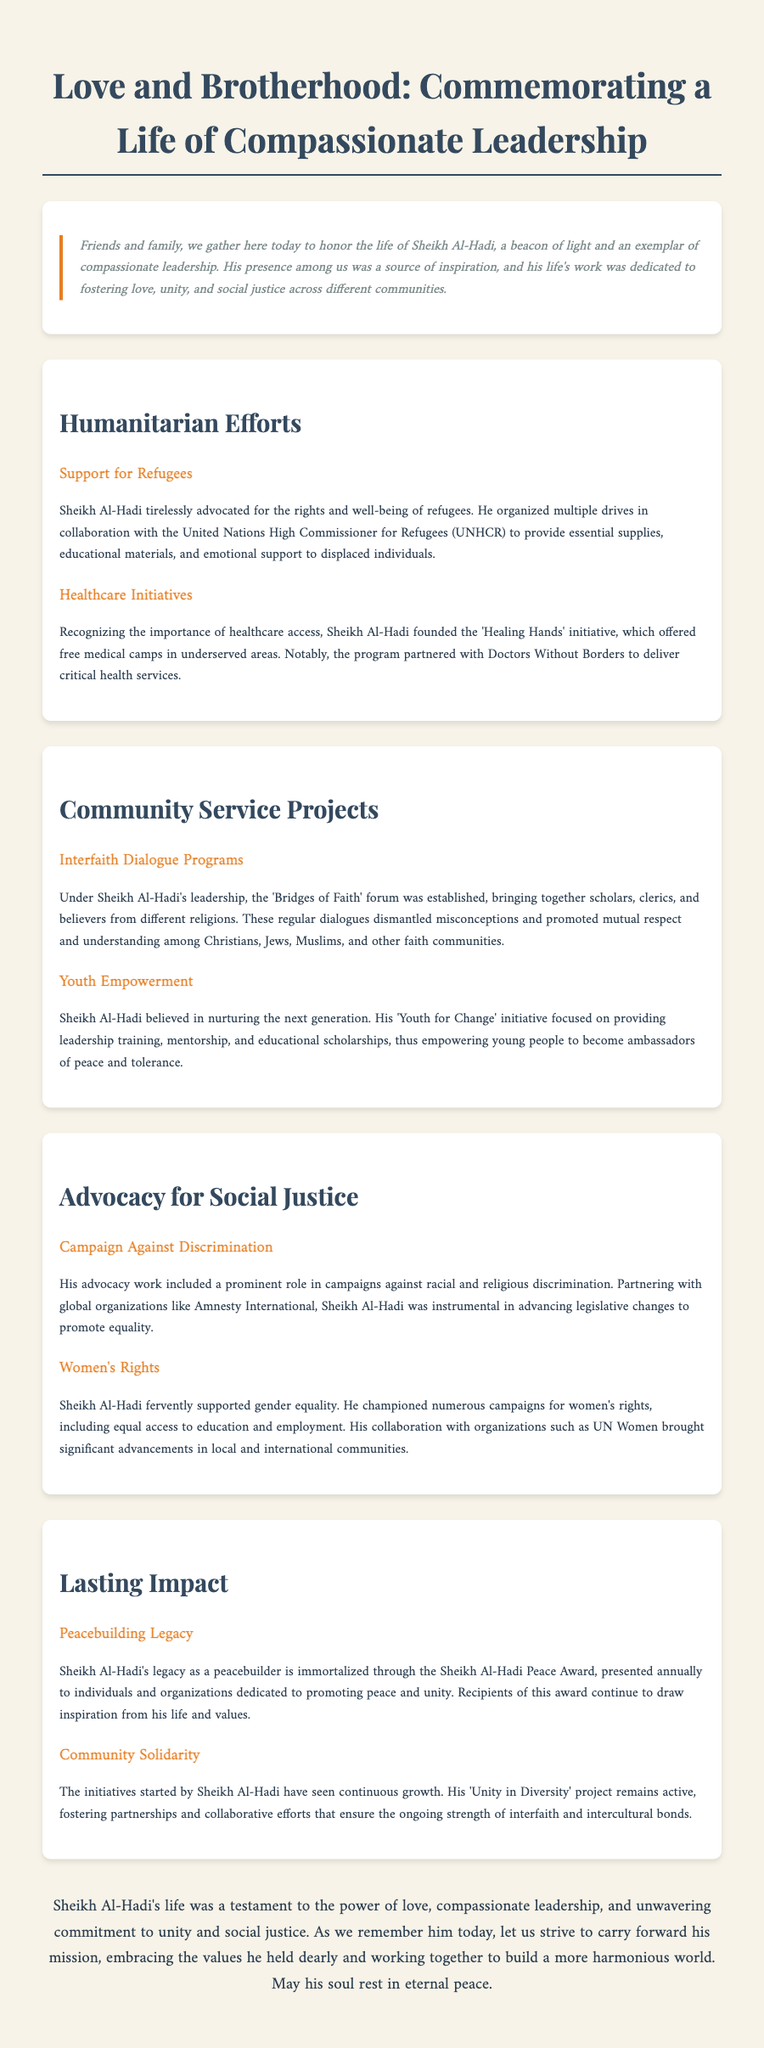What was the title of the eulogy? The title of the eulogy is prominently displayed at the top of the document.
Answer: Love and Brotherhood: Commemorating a Life of Compassionate Leadership Who organized drives for refugees? The document states that Sheikh Al-Hadi was the one who organized drives in collaboration with UNHCR.
Answer: Sheikh Al-Hadi What initiative focused on free medical camps? The document mentions a specific initiative that provided free medical camps to underserved areas.
Answer: Healing Hands What forum was established for interfaith dialogue? The eulogy specifies a forum created under Sheikh Al-Hadi's leadership for dialogue among different religions.
Answer: Bridges of Faith What award is presented annually in Sheikh Al-Hadi's honor? The document highlights an award that carries the Sheikh Al-Hadi's name for peacebuilding.
Answer: Sheikh Al-Hadi Peace Award How did Sheikh Al-Hadi contribute to women's rights? The eulogy outlines his efforts related to gender equality and education for women.
Answer: Campaigns for women's rights What project promotes community solidarity? A project mentioned in the eulogy signifies the continuation of Sheikh Al-Hadi's work in fostering unity.
Answer: Unity in Diversity What partnership was mentioned concerning healthcare initiatives? The document describes Sheikh Al-Hadi's healthcare efforts collaborating with a global organization.
Answer: Doctors Without Borders What was Sheikh Al-Hadi's approach to social justice? The eulogy describes specific campaigns related to equality and anti-discrimination led by him.
Answer: Advocacy against discrimination 